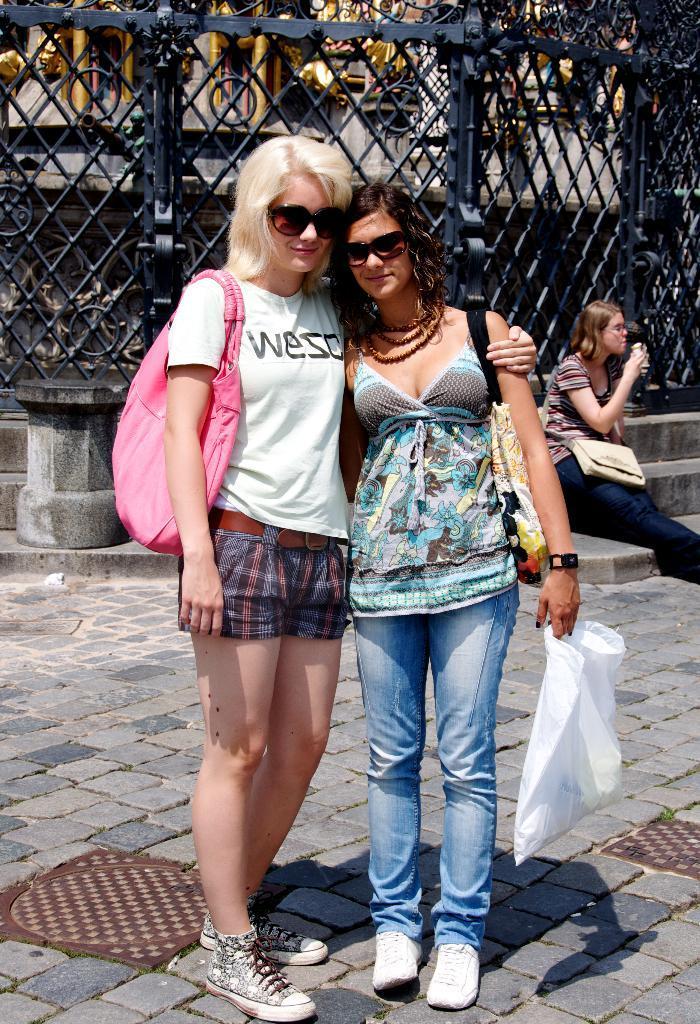How would you summarize this image in a sentence or two? In this image we can see two ladies standing. They are wearing goggles and bags. Lady on the right is holding packet. In the back there are steps. On the steps there is a person sitting and wearing a bag. In the back there is a small pillar. In the back there is a railing. 